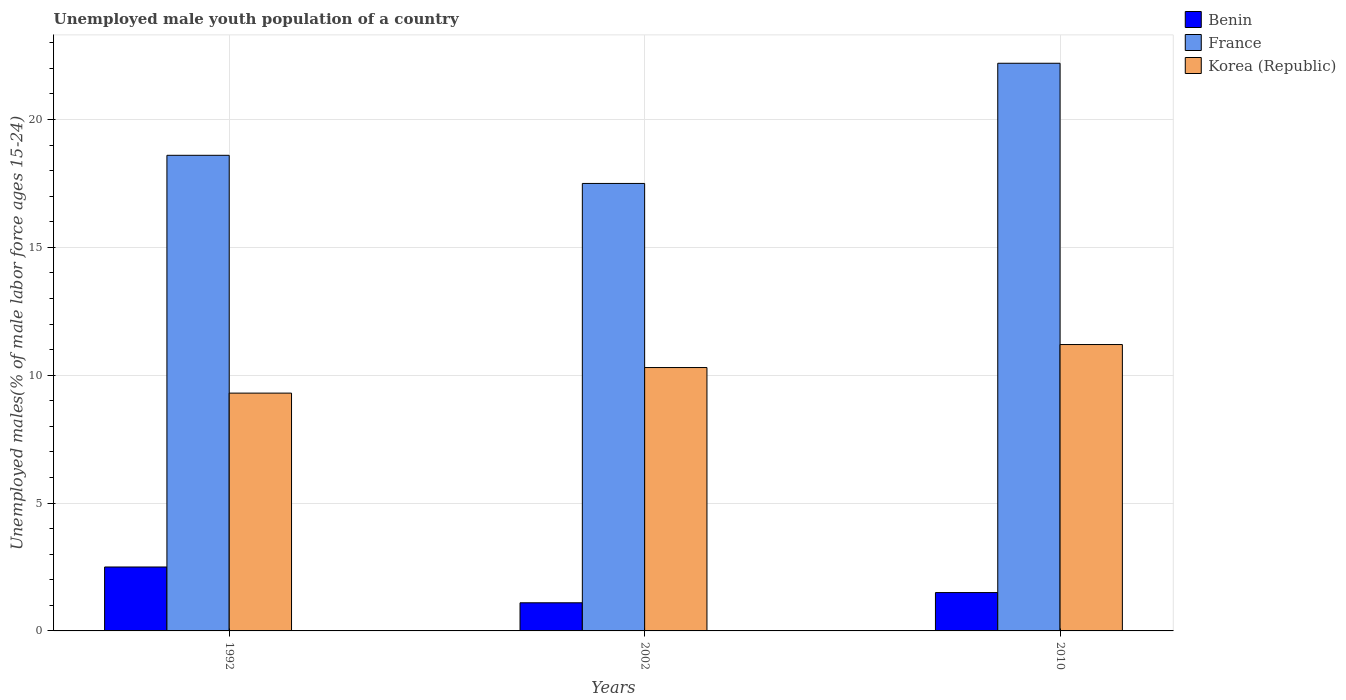How many different coloured bars are there?
Offer a terse response. 3. How many bars are there on the 2nd tick from the right?
Your response must be concise. 3. In how many cases, is the number of bars for a given year not equal to the number of legend labels?
Provide a succinct answer. 0. What is the percentage of unemployed male youth population in Korea (Republic) in 1992?
Your answer should be very brief. 9.3. Across all years, what is the maximum percentage of unemployed male youth population in Benin?
Keep it short and to the point. 2.5. Across all years, what is the minimum percentage of unemployed male youth population in Benin?
Provide a short and direct response. 1.1. What is the total percentage of unemployed male youth population in Korea (Republic) in the graph?
Offer a very short reply. 30.8. What is the difference between the percentage of unemployed male youth population in France in 1992 and that in 2002?
Your answer should be very brief. 1.1. What is the difference between the percentage of unemployed male youth population in France in 1992 and the percentage of unemployed male youth population in Korea (Republic) in 2002?
Provide a succinct answer. 8.3. What is the average percentage of unemployed male youth population in France per year?
Ensure brevity in your answer.  19.43. In the year 2002, what is the difference between the percentage of unemployed male youth population in France and percentage of unemployed male youth population in Benin?
Offer a very short reply. 16.4. In how many years, is the percentage of unemployed male youth population in Korea (Republic) greater than 1 %?
Make the answer very short. 3. What is the ratio of the percentage of unemployed male youth population in Korea (Republic) in 1992 to that in 2010?
Give a very brief answer. 0.83. What is the difference between the highest and the lowest percentage of unemployed male youth population in France?
Your response must be concise. 4.7. What does the 2nd bar from the left in 1992 represents?
Your answer should be very brief. France. What does the 1st bar from the right in 2002 represents?
Give a very brief answer. Korea (Republic). Are all the bars in the graph horizontal?
Keep it short and to the point. No. How many years are there in the graph?
Your answer should be very brief. 3. Does the graph contain any zero values?
Your answer should be very brief. No. Where does the legend appear in the graph?
Give a very brief answer. Top right. What is the title of the graph?
Provide a short and direct response. Unemployed male youth population of a country. Does "Somalia" appear as one of the legend labels in the graph?
Make the answer very short. No. What is the label or title of the X-axis?
Ensure brevity in your answer.  Years. What is the label or title of the Y-axis?
Your answer should be very brief. Unemployed males(% of male labor force ages 15-24). What is the Unemployed males(% of male labor force ages 15-24) in France in 1992?
Your answer should be compact. 18.6. What is the Unemployed males(% of male labor force ages 15-24) in Korea (Republic) in 1992?
Offer a terse response. 9.3. What is the Unemployed males(% of male labor force ages 15-24) of Benin in 2002?
Give a very brief answer. 1.1. What is the Unemployed males(% of male labor force ages 15-24) of France in 2002?
Provide a short and direct response. 17.5. What is the Unemployed males(% of male labor force ages 15-24) of Korea (Republic) in 2002?
Ensure brevity in your answer.  10.3. What is the Unemployed males(% of male labor force ages 15-24) in France in 2010?
Give a very brief answer. 22.2. What is the Unemployed males(% of male labor force ages 15-24) in Korea (Republic) in 2010?
Offer a terse response. 11.2. Across all years, what is the maximum Unemployed males(% of male labor force ages 15-24) in France?
Your answer should be very brief. 22.2. Across all years, what is the maximum Unemployed males(% of male labor force ages 15-24) of Korea (Republic)?
Your answer should be compact. 11.2. Across all years, what is the minimum Unemployed males(% of male labor force ages 15-24) of Benin?
Your response must be concise. 1.1. Across all years, what is the minimum Unemployed males(% of male labor force ages 15-24) in France?
Provide a succinct answer. 17.5. Across all years, what is the minimum Unemployed males(% of male labor force ages 15-24) in Korea (Republic)?
Your answer should be compact. 9.3. What is the total Unemployed males(% of male labor force ages 15-24) in France in the graph?
Provide a succinct answer. 58.3. What is the total Unemployed males(% of male labor force ages 15-24) of Korea (Republic) in the graph?
Provide a short and direct response. 30.8. What is the difference between the Unemployed males(% of male labor force ages 15-24) of Benin in 1992 and that in 2002?
Make the answer very short. 1.4. What is the difference between the Unemployed males(% of male labor force ages 15-24) of Korea (Republic) in 1992 and that in 2002?
Your answer should be compact. -1. What is the difference between the Unemployed males(% of male labor force ages 15-24) of Benin in 1992 and that in 2010?
Give a very brief answer. 1. What is the difference between the Unemployed males(% of male labor force ages 15-24) in France in 1992 and that in 2010?
Offer a very short reply. -3.6. What is the difference between the Unemployed males(% of male labor force ages 15-24) of Korea (Republic) in 1992 and that in 2010?
Offer a very short reply. -1.9. What is the difference between the Unemployed males(% of male labor force ages 15-24) in France in 2002 and that in 2010?
Offer a terse response. -4.7. What is the difference between the Unemployed males(% of male labor force ages 15-24) in Korea (Republic) in 2002 and that in 2010?
Give a very brief answer. -0.9. What is the difference between the Unemployed males(% of male labor force ages 15-24) in Benin in 1992 and the Unemployed males(% of male labor force ages 15-24) in Korea (Republic) in 2002?
Your answer should be very brief. -7.8. What is the difference between the Unemployed males(% of male labor force ages 15-24) in Benin in 1992 and the Unemployed males(% of male labor force ages 15-24) in France in 2010?
Make the answer very short. -19.7. What is the difference between the Unemployed males(% of male labor force ages 15-24) in Benin in 1992 and the Unemployed males(% of male labor force ages 15-24) in Korea (Republic) in 2010?
Keep it short and to the point. -8.7. What is the difference between the Unemployed males(% of male labor force ages 15-24) of Benin in 2002 and the Unemployed males(% of male labor force ages 15-24) of France in 2010?
Offer a very short reply. -21.1. What is the difference between the Unemployed males(% of male labor force ages 15-24) in Benin in 2002 and the Unemployed males(% of male labor force ages 15-24) in Korea (Republic) in 2010?
Give a very brief answer. -10.1. What is the average Unemployed males(% of male labor force ages 15-24) of Benin per year?
Keep it short and to the point. 1.7. What is the average Unemployed males(% of male labor force ages 15-24) in France per year?
Make the answer very short. 19.43. What is the average Unemployed males(% of male labor force ages 15-24) in Korea (Republic) per year?
Your answer should be very brief. 10.27. In the year 1992, what is the difference between the Unemployed males(% of male labor force ages 15-24) of Benin and Unemployed males(% of male labor force ages 15-24) of France?
Your response must be concise. -16.1. In the year 1992, what is the difference between the Unemployed males(% of male labor force ages 15-24) of Benin and Unemployed males(% of male labor force ages 15-24) of Korea (Republic)?
Keep it short and to the point. -6.8. In the year 1992, what is the difference between the Unemployed males(% of male labor force ages 15-24) in France and Unemployed males(% of male labor force ages 15-24) in Korea (Republic)?
Keep it short and to the point. 9.3. In the year 2002, what is the difference between the Unemployed males(% of male labor force ages 15-24) in Benin and Unemployed males(% of male labor force ages 15-24) in France?
Ensure brevity in your answer.  -16.4. In the year 2002, what is the difference between the Unemployed males(% of male labor force ages 15-24) in Benin and Unemployed males(% of male labor force ages 15-24) in Korea (Republic)?
Provide a short and direct response. -9.2. In the year 2002, what is the difference between the Unemployed males(% of male labor force ages 15-24) in France and Unemployed males(% of male labor force ages 15-24) in Korea (Republic)?
Make the answer very short. 7.2. In the year 2010, what is the difference between the Unemployed males(% of male labor force ages 15-24) in Benin and Unemployed males(% of male labor force ages 15-24) in France?
Provide a succinct answer. -20.7. In the year 2010, what is the difference between the Unemployed males(% of male labor force ages 15-24) in Benin and Unemployed males(% of male labor force ages 15-24) in Korea (Republic)?
Your response must be concise. -9.7. In the year 2010, what is the difference between the Unemployed males(% of male labor force ages 15-24) in France and Unemployed males(% of male labor force ages 15-24) in Korea (Republic)?
Offer a very short reply. 11. What is the ratio of the Unemployed males(% of male labor force ages 15-24) of Benin in 1992 to that in 2002?
Provide a short and direct response. 2.27. What is the ratio of the Unemployed males(% of male labor force ages 15-24) in France in 1992 to that in 2002?
Offer a terse response. 1.06. What is the ratio of the Unemployed males(% of male labor force ages 15-24) in Korea (Republic) in 1992 to that in 2002?
Provide a short and direct response. 0.9. What is the ratio of the Unemployed males(% of male labor force ages 15-24) in Benin in 1992 to that in 2010?
Your answer should be compact. 1.67. What is the ratio of the Unemployed males(% of male labor force ages 15-24) in France in 1992 to that in 2010?
Provide a short and direct response. 0.84. What is the ratio of the Unemployed males(% of male labor force ages 15-24) in Korea (Republic) in 1992 to that in 2010?
Your answer should be very brief. 0.83. What is the ratio of the Unemployed males(% of male labor force ages 15-24) in Benin in 2002 to that in 2010?
Provide a succinct answer. 0.73. What is the ratio of the Unemployed males(% of male labor force ages 15-24) of France in 2002 to that in 2010?
Offer a very short reply. 0.79. What is the ratio of the Unemployed males(% of male labor force ages 15-24) in Korea (Republic) in 2002 to that in 2010?
Ensure brevity in your answer.  0.92. What is the difference between the highest and the second highest Unemployed males(% of male labor force ages 15-24) in Benin?
Keep it short and to the point. 1. What is the difference between the highest and the lowest Unemployed males(% of male labor force ages 15-24) of Benin?
Your answer should be very brief. 1.4. 